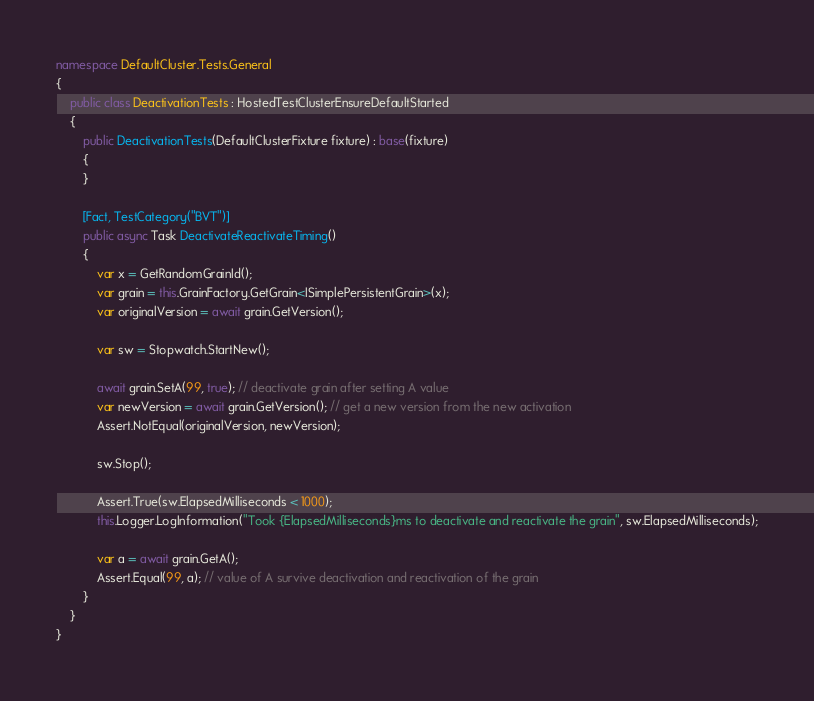<code> <loc_0><loc_0><loc_500><loc_500><_C#_>namespace DefaultCluster.Tests.General
{
    public class DeactivationTests : HostedTestClusterEnsureDefaultStarted
    {
        public DeactivationTests(DefaultClusterFixture fixture) : base(fixture)
        {
        }

        [Fact, TestCategory("BVT")]
        public async Task DeactivateReactivateTiming()
        {
            var x = GetRandomGrainId();
            var grain = this.GrainFactory.GetGrain<ISimplePersistentGrain>(x);
            var originalVersion = await grain.GetVersion();

            var sw = Stopwatch.StartNew();

            await grain.SetA(99, true); // deactivate grain after setting A value
            var newVersion = await grain.GetVersion(); // get a new version from the new activation
            Assert.NotEqual(originalVersion, newVersion);

            sw.Stop();

            Assert.True(sw.ElapsedMilliseconds < 1000);
            this.Logger.LogInformation("Took {ElapsedMilliseconds}ms to deactivate and reactivate the grain", sw.ElapsedMilliseconds);

            var a = await grain.GetA();
            Assert.Equal(99, a); // value of A survive deactivation and reactivation of the grain
        }
    }
}
</code> 